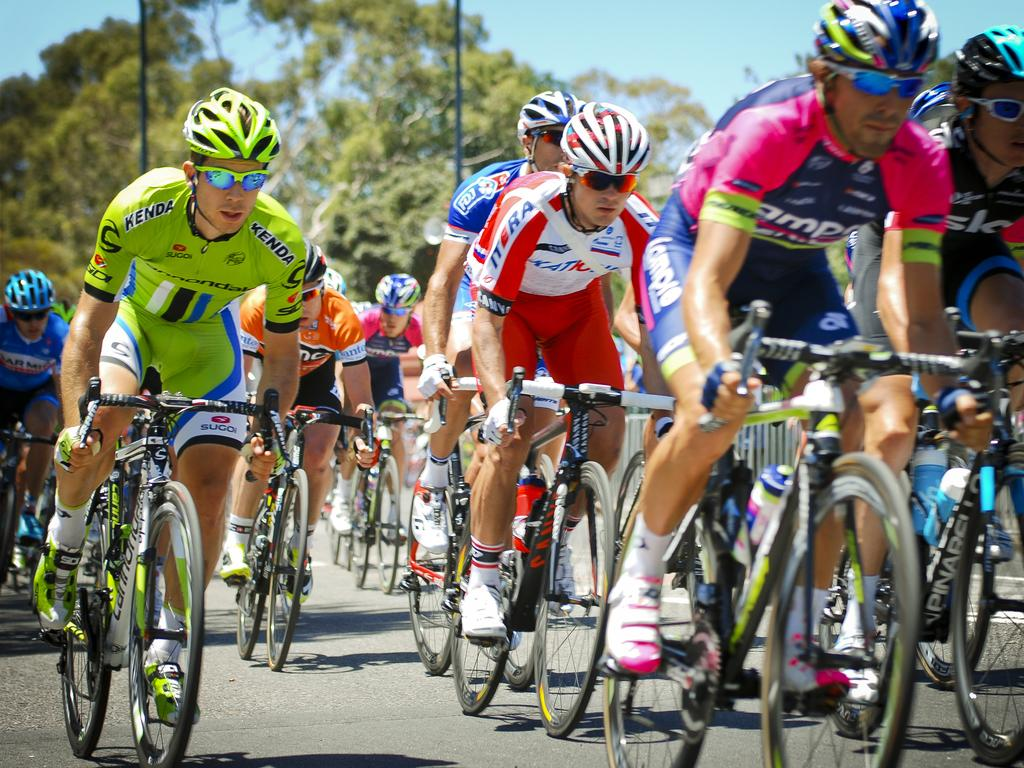How many people are in the image? There is a group of people in the image. What are the people wearing on their heads? The people are wearing helmets. What else are the people wearing? The people are wearing spectacles. What are the people doing in the image? The people are riding bicycles. Where are the bicycles located? The bicycles are on a road. What can be seen in the background of the image? There are trees and the sky visible in the background of the image. What type of stone is being used to hold the lettuce in the image? There is no stone or lettuce present in the image; it features a group of people riding bicycles on a road. 